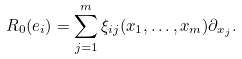<formula> <loc_0><loc_0><loc_500><loc_500>R _ { 0 } ( e _ { i } ) = \sum _ { j = 1 } ^ { m } \xi _ { i j } ( x _ { 1 } , \dots , x _ { m } ) \partial _ { x _ { j } } .</formula> 